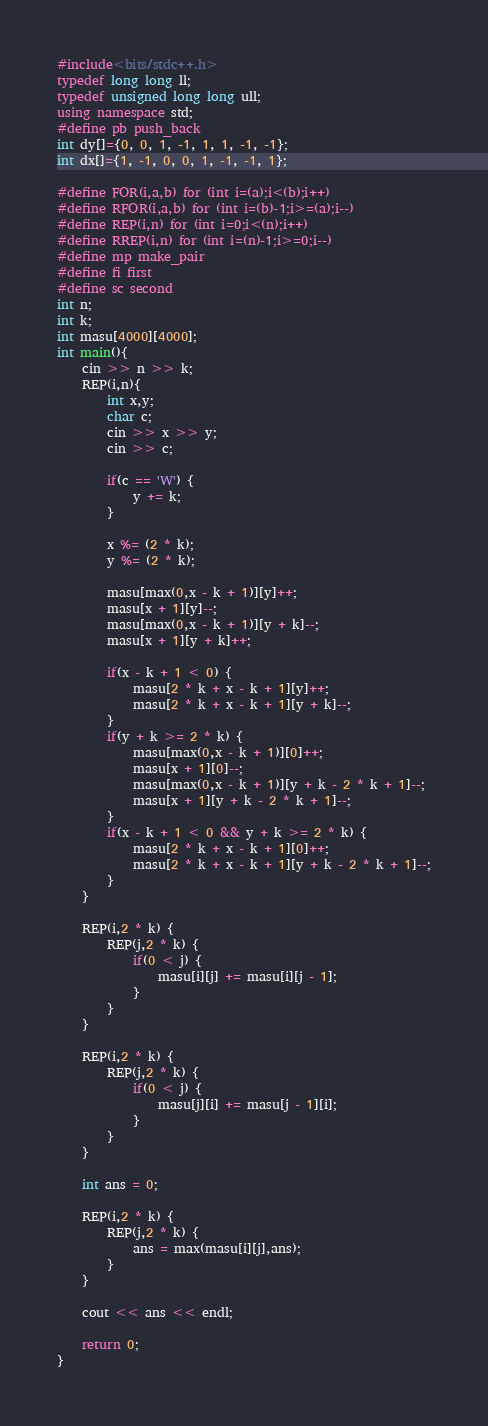Convert code to text. <code><loc_0><loc_0><loc_500><loc_500><_C++_>#include<bits/stdc++.h>
typedef long long ll;
typedef unsigned long long ull;
using namespace std;
#define pb push_back
int dy[]={0, 0, 1, -1, 1, 1, -1, -1};
int dx[]={1, -1, 0, 0, 1, -1, -1, 1};

#define FOR(i,a,b) for (int i=(a);i<(b);i++)
#define RFOR(i,a,b) for (int i=(b)-1;i>=(a);i--)
#define REP(i,n) for (int i=0;i<(n);i++)
#define RREP(i,n) for (int i=(n)-1;i>=0;i--)
#define mp make_pair
#define fi first
#define sc second
int n;
int k;
int masu[4000][4000];
int main(){
	cin >> n >> k;
	REP(i,n){
		int x,y;
		char c;
		cin >> x >> y;
		cin >> c;

		if(c == 'W') {
			y += k;
		}

		x %= (2 * k);
		y %= (2 * k);

		masu[max(0,x - k + 1)][y]++;
		masu[x + 1][y]--;
		masu[max(0,x - k + 1)][y + k]--;
		masu[x + 1][y + k]++;

		if(x - k + 1 < 0) {
			masu[2 * k + x - k + 1][y]++;
			masu[2 * k + x - k + 1][y + k]--;
		}
		if(y + k >= 2 * k) {
			masu[max(0,x - k + 1)][0]++;
			masu[x + 1][0]--;
			masu[max(0,x - k + 1)][y + k - 2 * k + 1]--;
			masu[x + 1][y + k - 2 * k + 1]--;
		}
		if(x - k + 1 < 0 && y + k >= 2 * k) {
			masu[2 * k + x - k + 1][0]++;
			masu[2 * k + x - k + 1][y + k - 2 * k + 1]--;
		}
	}

	REP(i,2 * k) {
		REP(j,2 * k) {
			if(0 < j) {
				masu[i][j] += masu[i][j - 1];
			}
		}
	}

	REP(i,2 * k) {
		REP(j,2 * k) {
			if(0 < j) {
				masu[j][i] += masu[j - 1][i];
			}
		}
	}

	int ans = 0;

	REP(i,2 * k) {
		REP(j,2 * k) {
			ans = max(masu[i][j],ans);
		}
	}

	cout << ans << endl;

	return 0;
}
</code> 